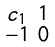Convert formula to latex. <formula><loc_0><loc_0><loc_500><loc_500>\begin{smallmatrix} c _ { 1 } & 1 \\ - 1 & 0 \end{smallmatrix}</formula> 